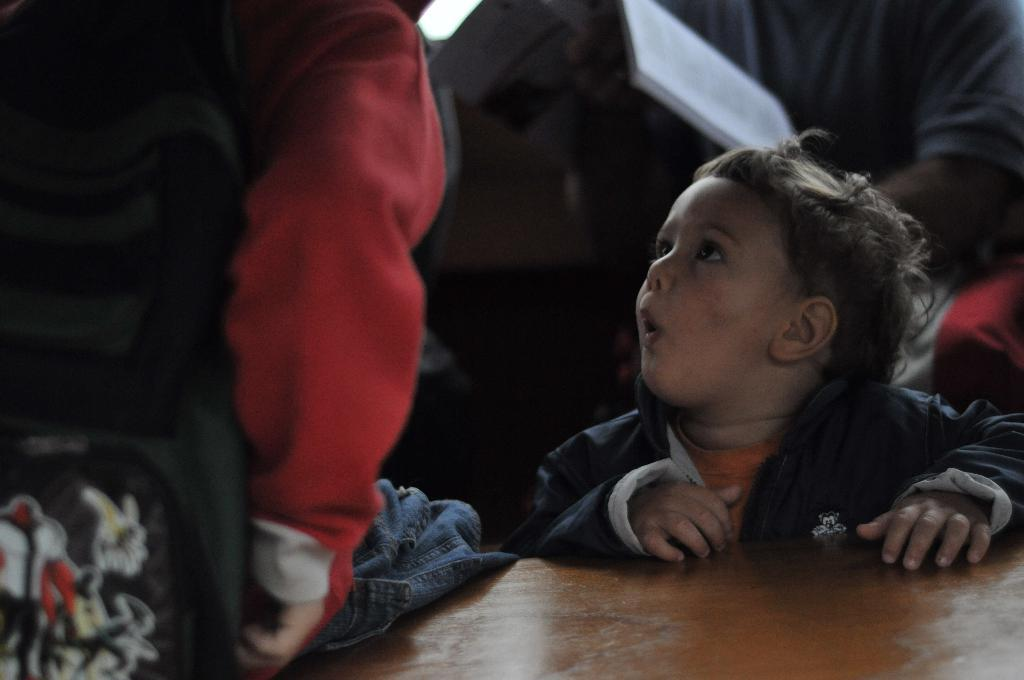Who or what can be seen in the image? There are people in the image. What item is visible in the image that might be used for carrying items? There is a bag in the image. What object can be seen in the image that might be used for reading or learning? There is a book in the image. What type of surface is present in the image? There is a wooden surface in the image. Can you describe any other objects that are visible in the image? There are unspecified objects in the image. What type of juice is being served in the crown in the image? There is no juice or crown present in the image. 